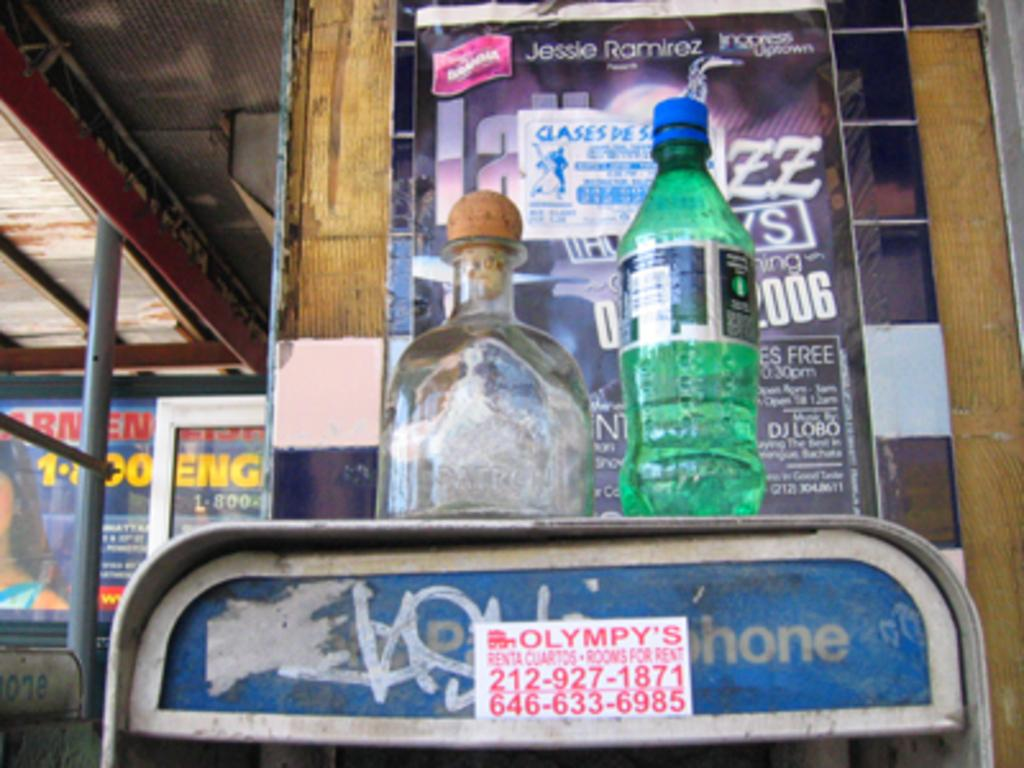<image>
Share a concise interpretation of the image provided. Olytmpy's room for rent sticker on a telephone 